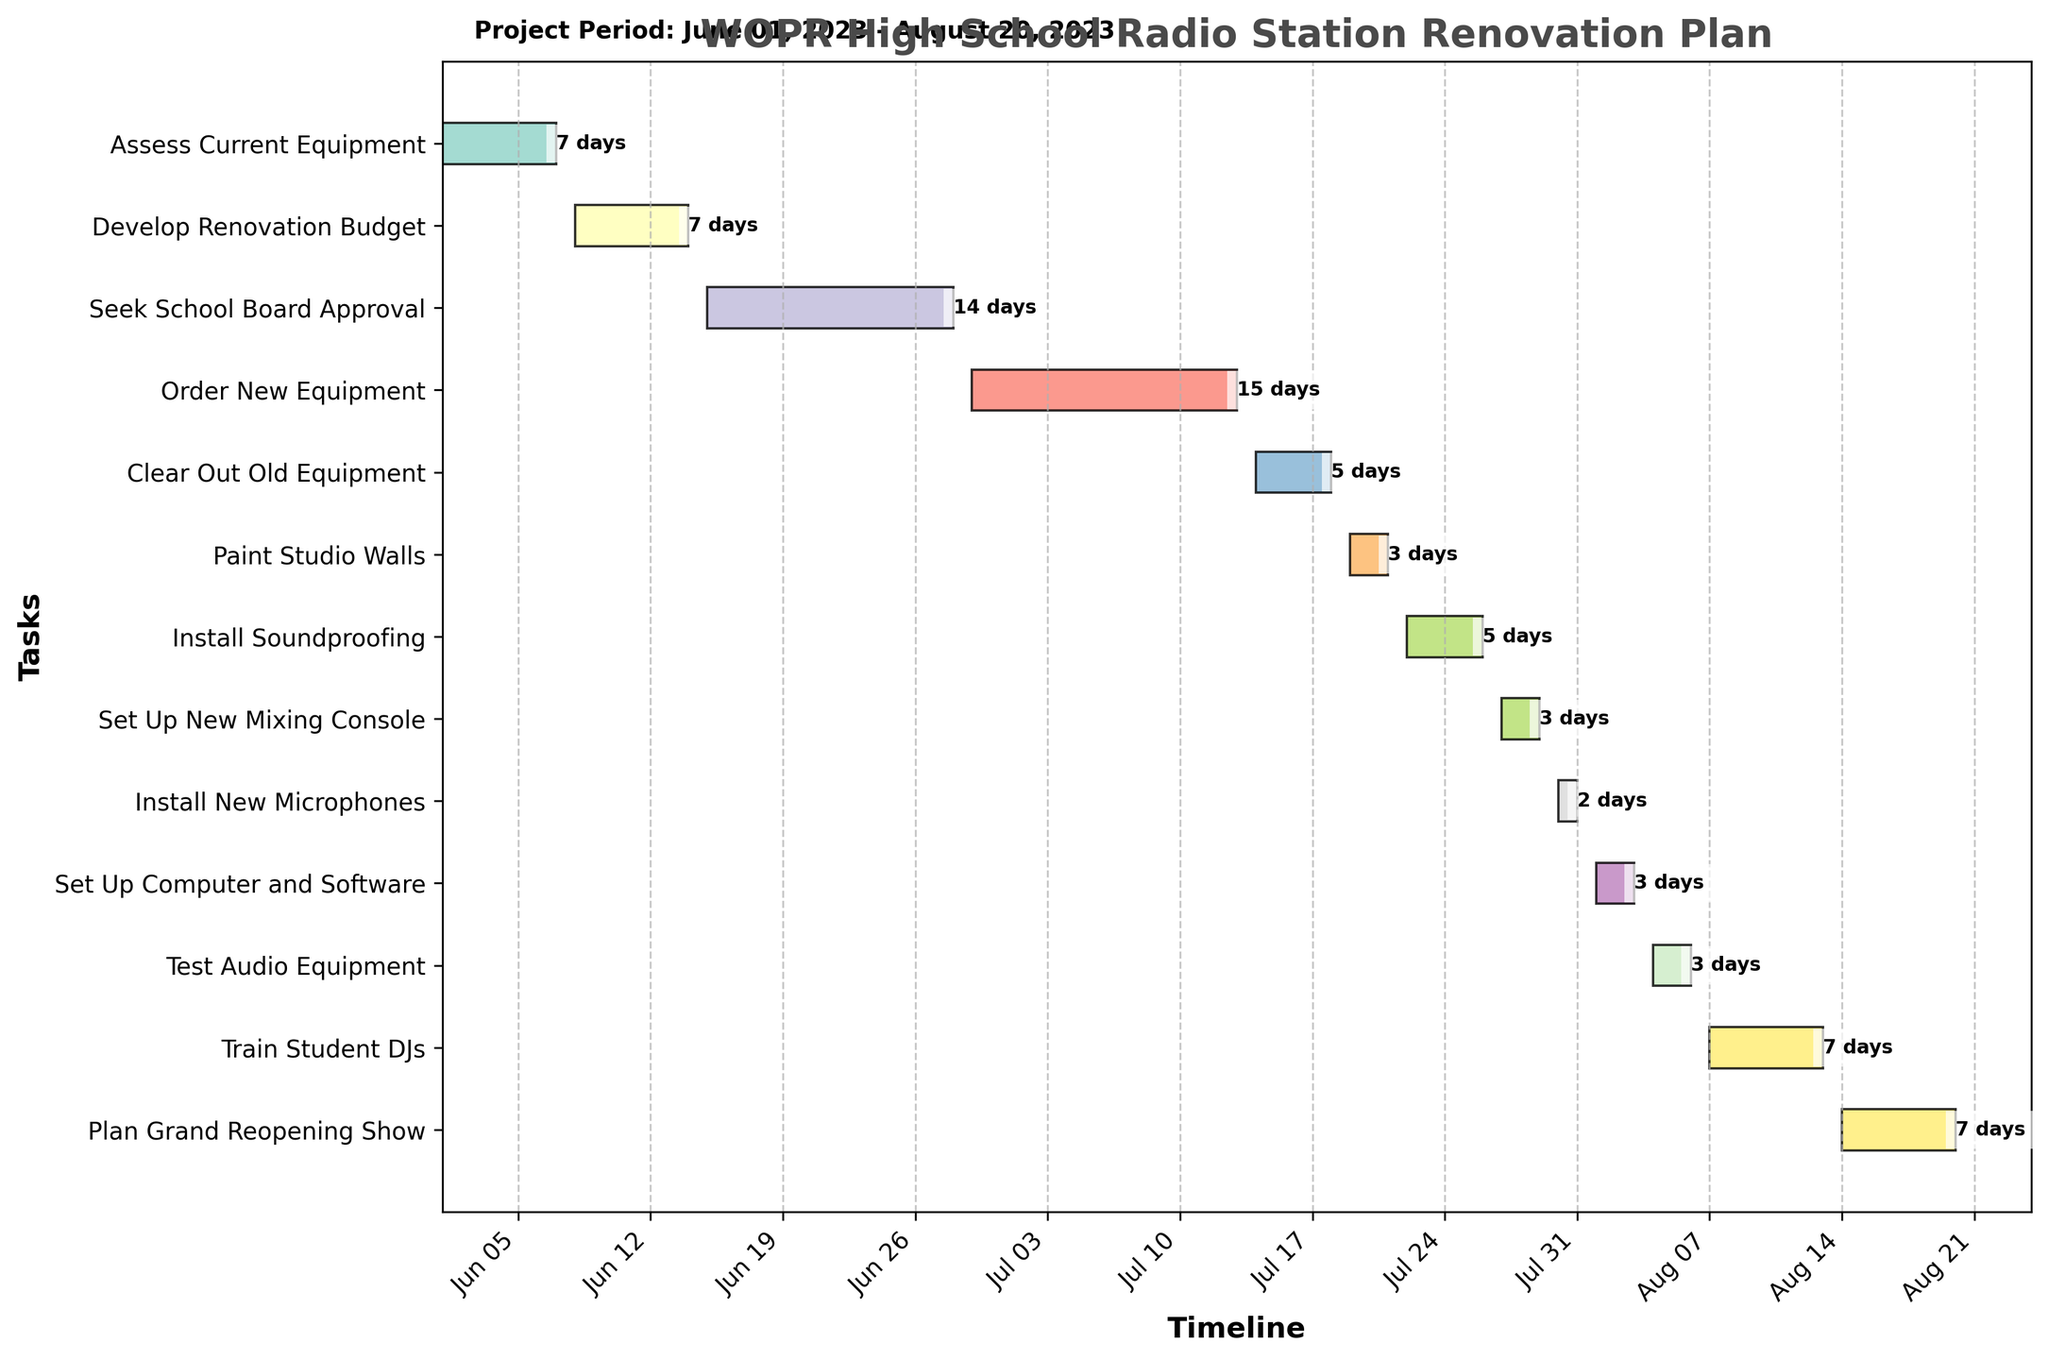Which task takes the longest time to complete? The task that takes the longest time can be identified by the length of the horizontal bar representing duration. From the chart, "Order New Equipment" takes 15 days, which is the longest.
Answer: Order New Equipment When does the "Install Soundproofing" task start and end? Look at the position of the horizontal bar for "Install Soundproofing." It starts on July 22 and ends on July 26.
Answer: Starts: July 22, Ends: July 26 How many tasks have a duration of exactly 7 days? Count the number of horizontal bars where the duration text next to them reads "7 days." The tasks are "Assess Current Equipment," "Develop Renovation Budget," "Train Student DJs," and "Plan Grand Reopening Show," making a total of 4.
Answer: 4 Which task follows immediately after "Order New Equipment"? The task that follows immediately after "Order New Equipment" is the next bar in sequence. The next task is "Clear Out Old Equipment."
Answer: Clear Out Old Equipment How many days are allocated to training the student DJs? Check the horizontal bar and its label next to the "Train Student DJs" task. It shows "7 days."
Answer: 7 days What is the total duration of all the tasks combined? Sum the durations of all tasks: 7 (Assess Current Equipment) + 7 (Develop Renovation Budget) + 14 (Seek School Board Approval) + 15 (Order New Equipment) + 5 (Clear Out Old Equipment) + 3 (Paint Studio Walls) + 5 (Install Soundproofing) + 3 (Set Up New Mixing Console) + 2 (Install New Microphones) + 3 (Set Up Computer and Software) + 3 (Test Audio Equipment) + 7 (Train Student DJs) + 7 (Plan Grand Reopening Show) = 81 days.
Answer: 81 days Which task has the shortest duration and how long is it? Identify the task with the smallest horizontal bar length. "Install New Microphones" lasts only 2 days.
Answer: Install New Microphones, 2 days Are there any tasks that overlap in the timeline? Observe if any bars start before the preceding one ends. "Order New Equipment" overlaps with both "Seek School Board Approval" and "Clear Out Old Equipment."
Answer: Yes, multiple overlaps What is the total duration from the start of the first task to the end of the last task? The project starts on June 1 and ends on August 20. Calculate the days between these dates. From June 1 to August 20 is 81 days (considering leap year).
Answer: 81 days Which task is planned immediately before "Test Audio Equipment"? The task scheduled just before "Test Audio Equipment" by examining the chart is "Set Up Computer and Software."
Answer: Set Up Computer and Software 